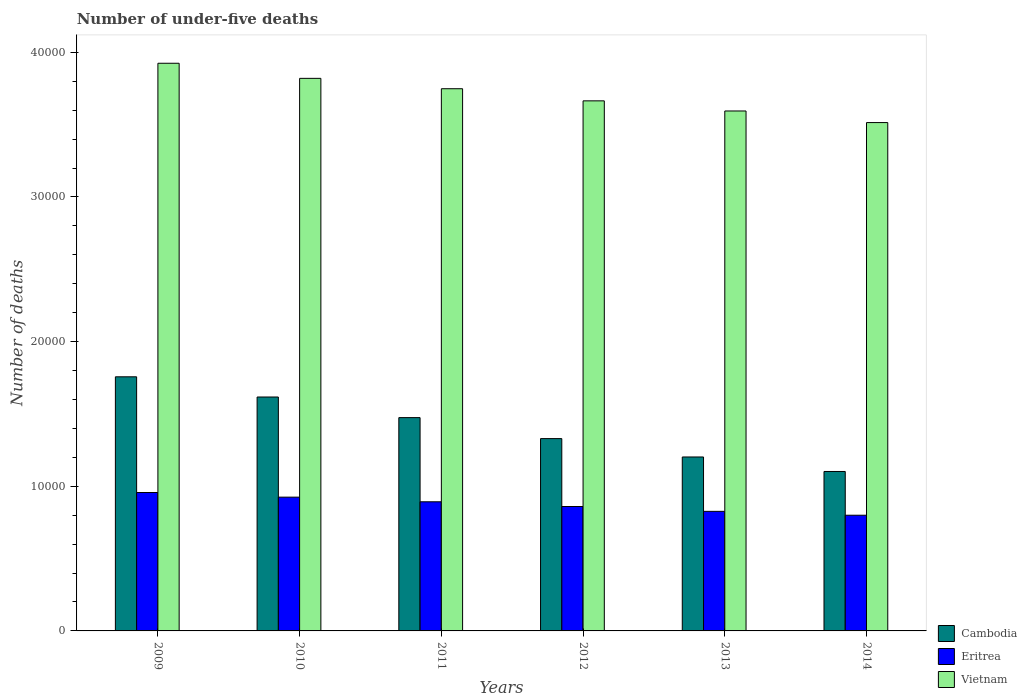How many different coloured bars are there?
Offer a terse response. 3. How many groups of bars are there?
Provide a short and direct response. 6. Are the number of bars on each tick of the X-axis equal?
Offer a terse response. Yes. In how many cases, is the number of bars for a given year not equal to the number of legend labels?
Your response must be concise. 0. What is the number of under-five deaths in Cambodia in 2011?
Your response must be concise. 1.47e+04. Across all years, what is the maximum number of under-five deaths in Eritrea?
Make the answer very short. 9569. Across all years, what is the minimum number of under-five deaths in Cambodia?
Keep it short and to the point. 1.10e+04. In which year was the number of under-five deaths in Vietnam minimum?
Provide a succinct answer. 2014. What is the total number of under-five deaths in Vietnam in the graph?
Offer a very short reply. 2.23e+05. What is the difference between the number of under-five deaths in Cambodia in 2009 and that in 2011?
Your response must be concise. 2821. What is the difference between the number of under-five deaths in Vietnam in 2009 and the number of under-five deaths in Cambodia in 2012?
Give a very brief answer. 2.59e+04. What is the average number of under-five deaths in Eritrea per year?
Give a very brief answer. 8768.17. In the year 2011, what is the difference between the number of under-five deaths in Eritrea and number of under-five deaths in Vietnam?
Keep it short and to the point. -2.86e+04. What is the ratio of the number of under-five deaths in Cambodia in 2011 to that in 2014?
Give a very brief answer. 1.34. What is the difference between the highest and the second highest number of under-five deaths in Cambodia?
Give a very brief answer. 1396. What is the difference between the highest and the lowest number of under-five deaths in Cambodia?
Your response must be concise. 6545. In how many years, is the number of under-five deaths in Cambodia greater than the average number of under-five deaths in Cambodia taken over all years?
Keep it short and to the point. 3. Is the sum of the number of under-five deaths in Vietnam in 2010 and 2013 greater than the maximum number of under-five deaths in Eritrea across all years?
Make the answer very short. Yes. What does the 3rd bar from the left in 2014 represents?
Make the answer very short. Vietnam. What does the 2nd bar from the right in 2010 represents?
Offer a very short reply. Eritrea. How many years are there in the graph?
Give a very brief answer. 6. What is the difference between two consecutive major ticks on the Y-axis?
Offer a terse response. 10000. Does the graph contain any zero values?
Keep it short and to the point. No. Does the graph contain grids?
Ensure brevity in your answer.  No. What is the title of the graph?
Ensure brevity in your answer.  Number of under-five deaths. What is the label or title of the X-axis?
Make the answer very short. Years. What is the label or title of the Y-axis?
Provide a short and direct response. Number of deaths. What is the Number of deaths of Cambodia in 2009?
Ensure brevity in your answer.  1.76e+04. What is the Number of deaths of Eritrea in 2009?
Offer a very short reply. 9569. What is the Number of deaths in Vietnam in 2009?
Provide a succinct answer. 3.92e+04. What is the Number of deaths in Cambodia in 2010?
Provide a short and direct response. 1.62e+04. What is the Number of deaths of Eritrea in 2010?
Offer a very short reply. 9248. What is the Number of deaths in Vietnam in 2010?
Provide a succinct answer. 3.82e+04. What is the Number of deaths of Cambodia in 2011?
Provide a succinct answer. 1.47e+04. What is the Number of deaths of Eritrea in 2011?
Give a very brief answer. 8927. What is the Number of deaths of Vietnam in 2011?
Provide a succinct answer. 3.75e+04. What is the Number of deaths of Cambodia in 2012?
Your answer should be compact. 1.33e+04. What is the Number of deaths of Eritrea in 2012?
Provide a short and direct response. 8601. What is the Number of deaths of Vietnam in 2012?
Provide a succinct answer. 3.66e+04. What is the Number of deaths in Cambodia in 2013?
Ensure brevity in your answer.  1.20e+04. What is the Number of deaths in Eritrea in 2013?
Provide a succinct answer. 8266. What is the Number of deaths in Vietnam in 2013?
Your answer should be very brief. 3.59e+04. What is the Number of deaths in Cambodia in 2014?
Offer a terse response. 1.10e+04. What is the Number of deaths in Eritrea in 2014?
Provide a succinct answer. 7998. What is the Number of deaths of Vietnam in 2014?
Offer a very short reply. 3.51e+04. Across all years, what is the maximum Number of deaths of Cambodia?
Give a very brief answer. 1.76e+04. Across all years, what is the maximum Number of deaths in Eritrea?
Your answer should be very brief. 9569. Across all years, what is the maximum Number of deaths of Vietnam?
Provide a short and direct response. 3.92e+04. Across all years, what is the minimum Number of deaths of Cambodia?
Keep it short and to the point. 1.10e+04. Across all years, what is the minimum Number of deaths of Eritrea?
Offer a very short reply. 7998. Across all years, what is the minimum Number of deaths in Vietnam?
Give a very brief answer. 3.51e+04. What is the total Number of deaths in Cambodia in the graph?
Provide a succinct answer. 8.48e+04. What is the total Number of deaths in Eritrea in the graph?
Provide a succinct answer. 5.26e+04. What is the total Number of deaths of Vietnam in the graph?
Keep it short and to the point. 2.23e+05. What is the difference between the Number of deaths of Cambodia in 2009 and that in 2010?
Make the answer very short. 1396. What is the difference between the Number of deaths of Eritrea in 2009 and that in 2010?
Make the answer very short. 321. What is the difference between the Number of deaths in Vietnam in 2009 and that in 2010?
Give a very brief answer. 1043. What is the difference between the Number of deaths of Cambodia in 2009 and that in 2011?
Provide a succinct answer. 2821. What is the difference between the Number of deaths in Eritrea in 2009 and that in 2011?
Your answer should be very brief. 642. What is the difference between the Number of deaths of Vietnam in 2009 and that in 2011?
Make the answer very short. 1761. What is the difference between the Number of deaths of Cambodia in 2009 and that in 2012?
Give a very brief answer. 4272. What is the difference between the Number of deaths of Eritrea in 2009 and that in 2012?
Your response must be concise. 968. What is the difference between the Number of deaths of Vietnam in 2009 and that in 2012?
Offer a very short reply. 2599. What is the difference between the Number of deaths in Cambodia in 2009 and that in 2013?
Offer a very short reply. 5542. What is the difference between the Number of deaths in Eritrea in 2009 and that in 2013?
Offer a terse response. 1303. What is the difference between the Number of deaths in Vietnam in 2009 and that in 2013?
Your answer should be compact. 3299. What is the difference between the Number of deaths in Cambodia in 2009 and that in 2014?
Provide a short and direct response. 6545. What is the difference between the Number of deaths in Eritrea in 2009 and that in 2014?
Keep it short and to the point. 1571. What is the difference between the Number of deaths in Vietnam in 2009 and that in 2014?
Your answer should be very brief. 4100. What is the difference between the Number of deaths in Cambodia in 2010 and that in 2011?
Make the answer very short. 1425. What is the difference between the Number of deaths in Eritrea in 2010 and that in 2011?
Offer a terse response. 321. What is the difference between the Number of deaths in Vietnam in 2010 and that in 2011?
Offer a very short reply. 718. What is the difference between the Number of deaths in Cambodia in 2010 and that in 2012?
Provide a succinct answer. 2876. What is the difference between the Number of deaths of Eritrea in 2010 and that in 2012?
Your answer should be very brief. 647. What is the difference between the Number of deaths in Vietnam in 2010 and that in 2012?
Your answer should be compact. 1556. What is the difference between the Number of deaths in Cambodia in 2010 and that in 2013?
Your answer should be very brief. 4146. What is the difference between the Number of deaths of Eritrea in 2010 and that in 2013?
Offer a terse response. 982. What is the difference between the Number of deaths of Vietnam in 2010 and that in 2013?
Offer a very short reply. 2256. What is the difference between the Number of deaths of Cambodia in 2010 and that in 2014?
Keep it short and to the point. 5149. What is the difference between the Number of deaths of Eritrea in 2010 and that in 2014?
Your response must be concise. 1250. What is the difference between the Number of deaths of Vietnam in 2010 and that in 2014?
Your response must be concise. 3057. What is the difference between the Number of deaths in Cambodia in 2011 and that in 2012?
Offer a very short reply. 1451. What is the difference between the Number of deaths of Eritrea in 2011 and that in 2012?
Provide a succinct answer. 326. What is the difference between the Number of deaths in Vietnam in 2011 and that in 2012?
Your response must be concise. 838. What is the difference between the Number of deaths in Cambodia in 2011 and that in 2013?
Make the answer very short. 2721. What is the difference between the Number of deaths of Eritrea in 2011 and that in 2013?
Provide a succinct answer. 661. What is the difference between the Number of deaths in Vietnam in 2011 and that in 2013?
Give a very brief answer. 1538. What is the difference between the Number of deaths in Cambodia in 2011 and that in 2014?
Offer a very short reply. 3724. What is the difference between the Number of deaths in Eritrea in 2011 and that in 2014?
Provide a succinct answer. 929. What is the difference between the Number of deaths of Vietnam in 2011 and that in 2014?
Offer a very short reply. 2339. What is the difference between the Number of deaths in Cambodia in 2012 and that in 2013?
Ensure brevity in your answer.  1270. What is the difference between the Number of deaths of Eritrea in 2012 and that in 2013?
Your answer should be very brief. 335. What is the difference between the Number of deaths in Vietnam in 2012 and that in 2013?
Provide a succinct answer. 700. What is the difference between the Number of deaths of Cambodia in 2012 and that in 2014?
Offer a very short reply. 2273. What is the difference between the Number of deaths of Eritrea in 2012 and that in 2014?
Give a very brief answer. 603. What is the difference between the Number of deaths of Vietnam in 2012 and that in 2014?
Ensure brevity in your answer.  1501. What is the difference between the Number of deaths in Cambodia in 2013 and that in 2014?
Ensure brevity in your answer.  1003. What is the difference between the Number of deaths of Eritrea in 2013 and that in 2014?
Provide a succinct answer. 268. What is the difference between the Number of deaths in Vietnam in 2013 and that in 2014?
Provide a short and direct response. 801. What is the difference between the Number of deaths in Cambodia in 2009 and the Number of deaths in Eritrea in 2010?
Keep it short and to the point. 8319. What is the difference between the Number of deaths in Cambodia in 2009 and the Number of deaths in Vietnam in 2010?
Keep it short and to the point. -2.06e+04. What is the difference between the Number of deaths of Eritrea in 2009 and the Number of deaths of Vietnam in 2010?
Provide a short and direct response. -2.86e+04. What is the difference between the Number of deaths in Cambodia in 2009 and the Number of deaths in Eritrea in 2011?
Your response must be concise. 8640. What is the difference between the Number of deaths of Cambodia in 2009 and the Number of deaths of Vietnam in 2011?
Provide a succinct answer. -1.99e+04. What is the difference between the Number of deaths in Eritrea in 2009 and the Number of deaths in Vietnam in 2011?
Your answer should be very brief. -2.79e+04. What is the difference between the Number of deaths of Cambodia in 2009 and the Number of deaths of Eritrea in 2012?
Your answer should be very brief. 8966. What is the difference between the Number of deaths of Cambodia in 2009 and the Number of deaths of Vietnam in 2012?
Your response must be concise. -1.91e+04. What is the difference between the Number of deaths in Eritrea in 2009 and the Number of deaths in Vietnam in 2012?
Ensure brevity in your answer.  -2.71e+04. What is the difference between the Number of deaths in Cambodia in 2009 and the Number of deaths in Eritrea in 2013?
Ensure brevity in your answer.  9301. What is the difference between the Number of deaths in Cambodia in 2009 and the Number of deaths in Vietnam in 2013?
Make the answer very short. -1.84e+04. What is the difference between the Number of deaths of Eritrea in 2009 and the Number of deaths of Vietnam in 2013?
Ensure brevity in your answer.  -2.64e+04. What is the difference between the Number of deaths of Cambodia in 2009 and the Number of deaths of Eritrea in 2014?
Your answer should be very brief. 9569. What is the difference between the Number of deaths in Cambodia in 2009 and the Number of deaths in Vietnam in 2014?
Make the answer very short. -1.76e+04. What is the difference between the Number of deaths of Eritrea in 2009 and the Number of deaths of Vietnam in 2014?
Make the answer very short. -2.56e+04. What is the difference between the Number of deaths of Cambodia in 2010 and the Number of deaths of Eritrea in 2011?
Provide a succinct answer. 7244. What is the difference between the Number of deaths of Cambodia in 2010 and the Number of deaths of Vietnam in 2011?
Offer a terse response. -2.13e+04. What is the difference between the Number of deaths in Eritrea in 2010 and the Number of deaths in Vietnam in 2011?
Provide a succinct answer. -2.82e+04. What is the difference between the Number of deaths of Cambodia in 2010 and the Number of deaths of Eritrea in 2012?
Offer a very short reply. 7570. What is the difference between the Number of deaths in Cambodia in 2010 and the Number of deaths in Vietnam in 2012?
Your answer should be compact. -2.05e+04. What is the difference between the Number of deaths in Eritrea in 2010 and the Number of deaths in Vietnam in 2012?
Your answer should be compact. -2.74e+04. What is the difference between the Number of deaths of Cambodia in 2010 and the Number of deaths of Eritrea in 2013?
Your answer should be compact. 7905. What is the difference between the Number of deaths of Cambodia in 2010 and the Number of deaths of Vietnam in 2013?
Make the answer very short. -1.98e+04. What is the difference between the Number of deaths of Eritrea in 2010 and the Number of deaths of Vietnam in 2013?
Your answer should be very brief. -2.67e+04. What is the difference between the Number of deaths in Cambodia in 2010 and the Number of deaths in Eritrea in 2014?
Offer a very short reply. 8173. What is the difference between the Number of deaths of Cambodia in 2010 and the Number of deaths of Vietnam in 2014?
Offer a very short reply. -1.90e+04. What is the difference between the Number of deaths of Eritrea in 2010 and the Number of deaths of Vietnam in 2014?
Ensure brevity in your answer.  -2.59e+04. What is the difference between the Number of deaths in Cambodia in 2011 and the Number of deaths in Eritrea in 2012?
Ensure brevity in your answer.  6145. What is the difference between the Number of deaths in Cambodia in 2011 and the Number of deaths in Vietnam in 2012?
Your response must be concise. -2.19e+04. What is the difference between the Number of deaths in Eritrea in 2011 and the Number of deaths in Vietnam in 2012?
Your answer should be compact. -2.77e+04. What is the difference between the Number of deaths of Cambodia in 2011 and the Number of deaths of Eritrea in 2013?
Make the answer very short. 6480. What is the difference between the Number of deaths in Cambodia in 2011 and the Number of deaths in Vietnam in 2013?
Provide a short and direct response. -2.12e+04. What is the difference between the Number of deaths of Eritrea in 2011 and the Number of deaths of Vietnam in 2013?
Provide a succinct answer. -2.70e+04. What is the difference between the Number of deaths of Cambodia in 2011 and the Number of deaths of Eritrea in 2014?
Your answer should be compact. 6748. What is the difference between the Number of deaths in Cambodia in 2011 and the Number of deaths in Vietnam in 2014?
Your response must be concise. -2.04e+04. What is the difference between the Number of deaths of Eritrea in 2011 and the Number of deaths of Vietnam in 2014?
Ensure brevity in your answer.  -2.62e+04. What is the difference between the Number of deaths in Cambodia in 2012 and the Number of deaths in Eritrea in 2013?
Give a very brief answer. 5029. What is the difference between the Number of deaths in Cambodia in 2012 and the Number of deaths in Vietnam in 2013?
Make the answer very short. -2.26e+04. What is the difference between the Number of deaths of Eritrea in 2012 and the Number of deaths of Vietnam in 2013?
Your answer should be compact. -2.73e+04. What is the difference between the Number of deaths in Cambodia in 2012 and the Number of deaths in Eritrea in 2014?
Provide a short and direct response. 5297. What is the difference between the Number of deaths of Cambodia in 2012 and the Number of deaths of Vietnam in 2014?
Make the answer very short. -2.18e+04. What is the difference between the Number of deaths in Eritrea in 2012 and the Number of deaths in Vietnam in 2014?
Your answer should be very brief. -2.65e+04. What is the difference between the Number of deaths in Cambodia in 2013 and the Number of deaths in Eritrea in 2014?
Keep it short and to the point. 4027. What is the difference between the Number of deaths of Cambodia in 2013 and the Number of deaths of Vietnam in 2014?
Offer a terse response. -2.31e+04. What is the difference between the Number of deaths of Eritrea in 2013 and the Number of deaths of Vietnam in 2014?
Your response must be concise. -2.69e+04. What is the average Number of deaths in Cambodia per year?
Offer a terse response. 1.41e+04. What is the average Number of deaths in Eritrea per year?
Give a very brief answer. 8768.17. What is the average Number of deaths of Vietnam per year?
Offer a very short reply. 3.71e+04. In the year 2009, what is the difference between the Number of deaths of Cambodia and Number of deaths of Eritrea?
Your response must be concise. 7998. In the year 2009, what is the difference between the Number of deaths of Cambodia and Number of deaths of Vietnam?
Your response must be concise. -2.17e+04. In the year 2009, what is the difference between the Number of deaths of Eritrea and Number of deaths of Vietnam?
Your answer should be very brief. -2.97e+04. In the year 2010, what is the difference between the Number of deaths of Cambodia and Number of deaths of Eritrea?
Offer a very short reply. 6923. In the year 2010, what is the difference between the Number of deaths of Cambodia and Number of deaths of Vietnam?
Your answer should be compact. -2.20e+04. In the year 2010, what is the difference between the Number of deaths in Eritrea and Number of deaths in Vietnam?
Your response must be concise. -2.90e+04. In the year 2011, what is the difference between the Number of deaths in Cambodia and Number of deaths in Eritrea?
Provide a succinct answer. 5819. In the year 2011, what is the difference between the Number of deaths in Cambodia and Number of deaths in Vietnam?
Your answer should be compact. -2.27e+04. In the year 2011, what is the difference between the Number of deaths of Eritrea and Number of deaths of Vietnam?
Make the answer very short. -2.86e+04. In the year 2012, what is the difference between the Number of deaths of Cambodia and Number of deaths of Eritrea?
Your answer should be compact. 4694. In the year 2012, what is the difference between the Number of deaths of Cambodia and Number of deaths of Vietnam?
Make the answer very short. -2.33e+04. In the year 2012, what is the difference between the Number of deaths in Eritrea and Number of deaths in Vietnam?
Provide a succinct answer. -2.80e+04. In the year 2013, what is the difference between the Number of deaths in Cambodia and Number of deaths in Eritrea?
Keep it short and to the point. 3759. In the year 2013, what is the difference between the Number of deaths in Cambodia and Number of deaths in Vietnam?
Your answer should be very brief. -2.39e+04. In the year 2013, what is the difference between the Number of deaths in Eritrea and Number of deaths in Vietnam?
Your answer should be very brief. -2.77e+04. In the year 2014, what is the difference between the Number of deaths in Cambodia and Number of deaths in Eritrea?
Provide a succinct answer. 3024. In the year 2014, what is the difference between the Number of deaths in Cambodia and Number of deaths in Vietnam?
Offer a very short reply. -2.41e+04. In the year 2014, what is the difference between the Number of deaths in Eritrea and Number of deaths in Vietnam?
Make the answer very short. -2.71e+04. What is the ratio of the Number of deaths in Cambodia in 2009 to that in 2010?
Make the answer very short. 1.09. What is the ratio of the Number of deaths of Eritrea in 2009 to that in 2010?
Give a very brief answer. 1.03. What is the ratio of the Number of deaths of Vietnam in 2009 to that in 2010?
Give a very brief answer. 1.03. What is the ratio of the Number of deaths of Cambodia in 2009 to that in 2011?
Provide a succinct answer. 1.19. What is the ratio of the Number of deaths of Eritrea in 2009 to that in 2011?
Offer a terse response. 1.07. What is the ratio of the Number of deaths of Vietnam in 2009 to that in 2011?
Offer a very short reply. 1.05. What is the ratio of the Number of deaths of Cambodia in 2009 to that in 2012?
Offer a very short reply. 1.32. What is the ratio of the Number of deaths of Eritrea in 2009 to that in 2012?
Provide a succinct answer. 1.11. What is the ratio of the Number of deaths of Vietnam in 2009 to that in 2012?
Offer a terse response. 1.07. What is the ratio of the Number of deaths of Cambodia in 2009 to that in 2013?
Offer a very short reply. 1.46. What is the ratio of the Number of deaths of Eritrea in 2009 to that in 2013?
Provide a succinct answer. 1.16. What is the ratio of the Number of deaths of Vietnam in 2009 to that in 2013?
Your answer should be compact. 1.09. What is the ratio of the Number of deaths of Cambodia in 2009 to that in 2014?
Offer a terse response. 1.59. What is the ratio of the Number of deaths in Eritrea in 2009 to that in 2014?
Provide a succinct answer. 1.2. What is the ratio of the Number of deaths in Vietnam in 2009 to that in 2014?
Provide a succinct answer. 1.12. What is the ratio of the Number of deaths of Cambodia in 2010 to that in 2011?
Provide a succinct answer. 1.1. What is the ratio of the Number of deaths in Eritrea in 2010 to that in 2011?
Provide a short and direct response. 1.04. What is the ratio of the Number of deaths in Vietnam in 2010 to that in 2011?
Give a very brief answer. 1.02. What is the ratio of the Number of deaths of Cambodia in 2010 to that in 2012?
Give a very brief answer. 1.22. What is the ratio of the Number of deaths in Eritrea in 2010 to that in 2012?
Give a very brief answer. 1.08. What is the ratio of the Number of deaths of Vietnam in 2010 to that in 2012?
Offer a terse response. 1.04. What is the ratio of the Number of deaths in Cambodia in 2010 to that in 2013?
Offer a terse response. 1.34. What is the ratio of the Number of deaths in Eritrea in 2010 to that in 2013?
Make the answer very short. 1.12. What is the ratio of the Number of deaths in Vietnam in 2010 to that in 2013?
Give a very brief answer. 1.06. What is the ratio of the Number of deaths in Cambodia in 2010 to that in 2014?
Ensure brevity in your answer.  1.47. What is the ratio of the Number of deaths in Eritrea in 2010 to that in 2014?
Keep it short and to the point. 1.16. What is the ratio of the Number of deaths in Vietnam in 2010 to that in 2014?
Your answer should be compact. 1.09. What is the ratio of the Number of deaths of Cambodia in 2011 to that in 2012?
Your answer should be compact. 1.11. What is the ratio of the Number of deaths in Eritrea in 2011 to that in 2012?
Provide a succinct answer. 1.04. What is the ratio of the Number of deaths in Vietnam in 2011 to that in 2012?
Ensure brevity in your answer.  1.02. What is the ratio of the Number of deaths of Cambodia in 2011 to that in 2013?
Keep it short and to the point. 1.23. What is the ratio of the Number of deaths of Eritrea in 2011 to that in 2013?
Provide a succinct answer. 1.08. What is the ratio of the Number of deaths of Vietnam in 2011 to that in 2013?
Offer a terse response. 1.04. What is the ratio of the Number of deaths in Cambodia in 2011 to that in 2014?
Offer a very short reply. 1.34. What is the ratio of the Number of deaths in Eritrea in 2011 to that in 2014?
Give a very brief answer. 1.12. What is the ratio of the Number of deaths of Vietnam in 2011 to that in 2014?
Offer a terse response. 1.07. What is the ratio of the Number of deaths of Cambodia in 2012 to that in 2013?
Make the answer very short. 1.11. What is the ratio of the Number of deaths of Eritrea in 2012 to that in 2013?
Your answer should be very brief. 1.04. What is the ratio of the Number of deaths of Vietnam in 2012 to that in 2013?
Your answer should be compact. 1.02. What is the ratio of the Number of deaths of Cambodia in 2012 to that in 2014?
Your answer should be very brief. 1.21. What is the ratio of the Number of deaths in Eritrea in 2012 to that in 2014?
Provide a short and direct response. 1.08. What is the ratio of the Number of deaths of Vietnam in 2012 to that in 2014?
Offer a terse response. 1.04. What is the ratio of the Number of deaths of Cambodia in 2013 to that in 2014?
Provide a short and direct response. 1.09. What is the ratio of the Number of deaths in Eritrea in 2013 to that in 2014?
Your answer should be compact. 1.03. What is the ratio of the Number of deaths in Vietnam in 2013 to that in 2014?
Offer a terse response. 1.02. What is the difference between the highest and the second highest Number of deaths of Cambodia?
Your answer should be very brief. 1396. What is the difference between the highest and the second highest Number of deaths in Eritrea?
Provide a succinct answer. 321. What is the difference between the highest and the second highest Number of deaths of Vietnam?
Your answer should be very brief. 1043. What is the difference between the highest and the lowest Number of deaths in Cambodia?
Your answer should be very brief. 6545. What is the difference between the highest and the lowest Number of deaths in Eritrea?
Ensure brevity in your answer.  1571. What is the difference between the highest and the lowest Number of deaths of Vietnam?
Your answer should be compact. 4100. 